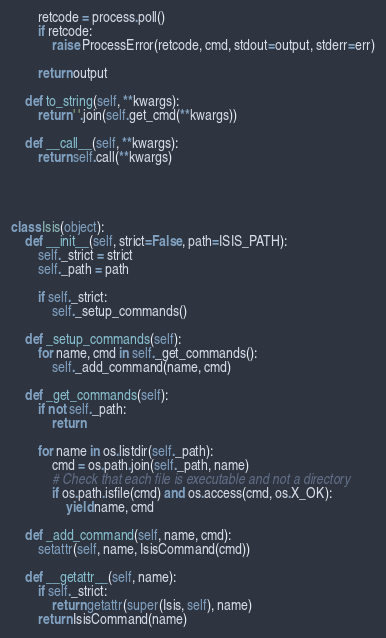Convert code to text. <code><loc_0><loc_0><loc_500><loc_500><_Python_>
        retcode = process.poll()
        if retcode:
            raise ProcessError(retcode, cmd, stdout=output, stderr=err)

        return output

    def to_string(self, **kwargs):
        return ' '.join(self.get_cmd(**kwargs))

    def __call__(self, **kwargs):
        return self.call(**kwargs)




class Isis(object):
    def __init__(self, strict=False, path=ISIS_PATH):
        self._strict = strict
        self._path = path

        if self._strict:
            self._setup_commands()

    def _setup_commands(self):
        for name, cmd in self._get_commands():
            self._add_command(name, cmd)

    def _get_commands(self):
        if not self._path:
            return

        for name in os.listdir(self._path):
            cmd = os.path.join(self._path, name)
            # Check that each file is executable and not a directory
            if os.path.isfile(cmd) and os.access(cmd, os.X_OK):
                yield name, cmd

    def _add_command(self, name, cmd):
        setattr(self, name, IsisCommand(cmd))

    def __getattr__(self, name):
        if self._strict:
            return getattr(super(Isis, self), name)
        return IsisCommand(name)
</code> 